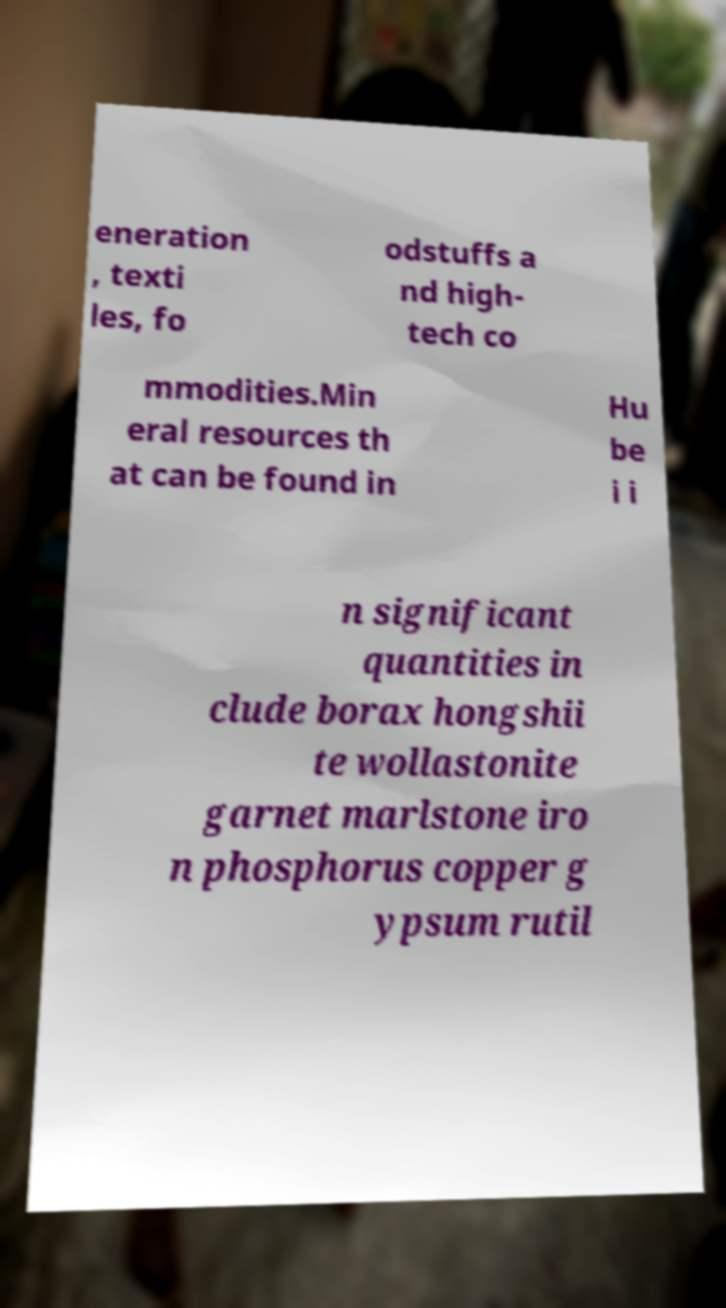There's text embedded in this image that I need extracted. Can you transcribe it verbatim? eneration , texti les, fo odstuffs a nd high- tech co mmodities.Min eral resources th at can be found in Hu be i i n significant quantities in clude borax hongshii te wollastonite garnet marlstone iro n phosphorus copper g ypsum rutil 